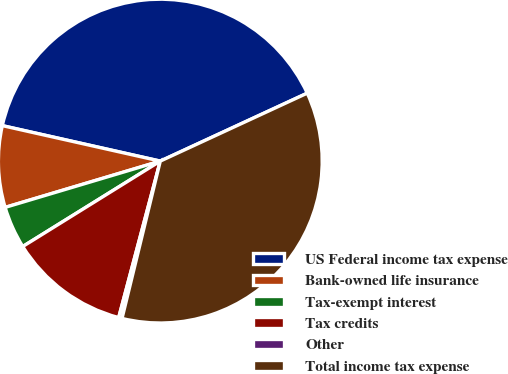Convert chart. <chart><loc_0><loc_0><loc_500><loc_500><pie_chart><fcel>US Federal income tax expense<fcel>Bank-owned life insurance<fcel>Tax-exempt interest<fcel>Tax credits<fcel>Other<fcel>Total income tax expense<nl><fcel>39.59%<fcel>8.13%<fcel>4.23%<fcel>12.02%<fcel>0.34%<fcel>35.69%<nl></chart> 